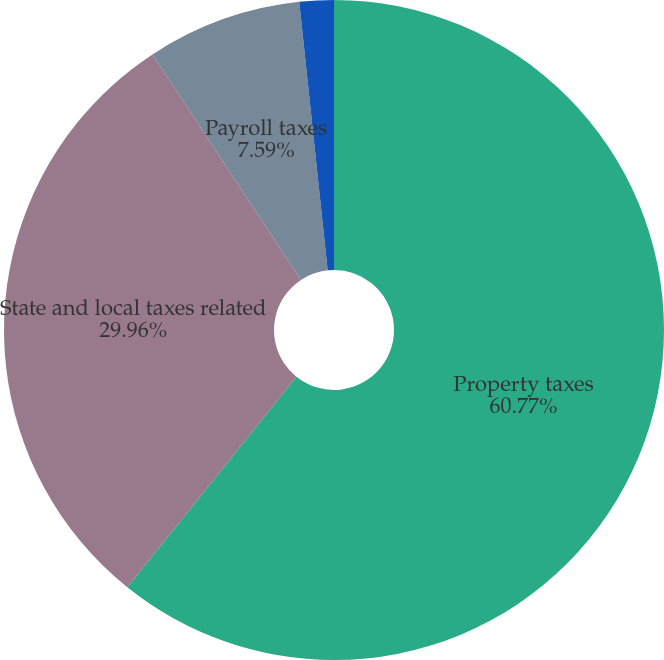<chart> <loc_0><loc_0><loc_500><loc_500><pie_chart><fcel>Property taxes<fcel>State and local taxes related<fcel>Payroll taxes<fcel>Other taxes<nl><fcel>60.77%<fcel>29.96%<fcel>7.59%<fcel>1.68%<nl></chart> 